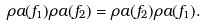<formula> <loc_0><loc_0><loc_500><loc_500>\rho a ( f _ { 1 } ) \rho a ( f _ { 2 } ) = \rho a ( f _ { 2 } ) \rho a ( f _ { 1 } ) .</formula> 